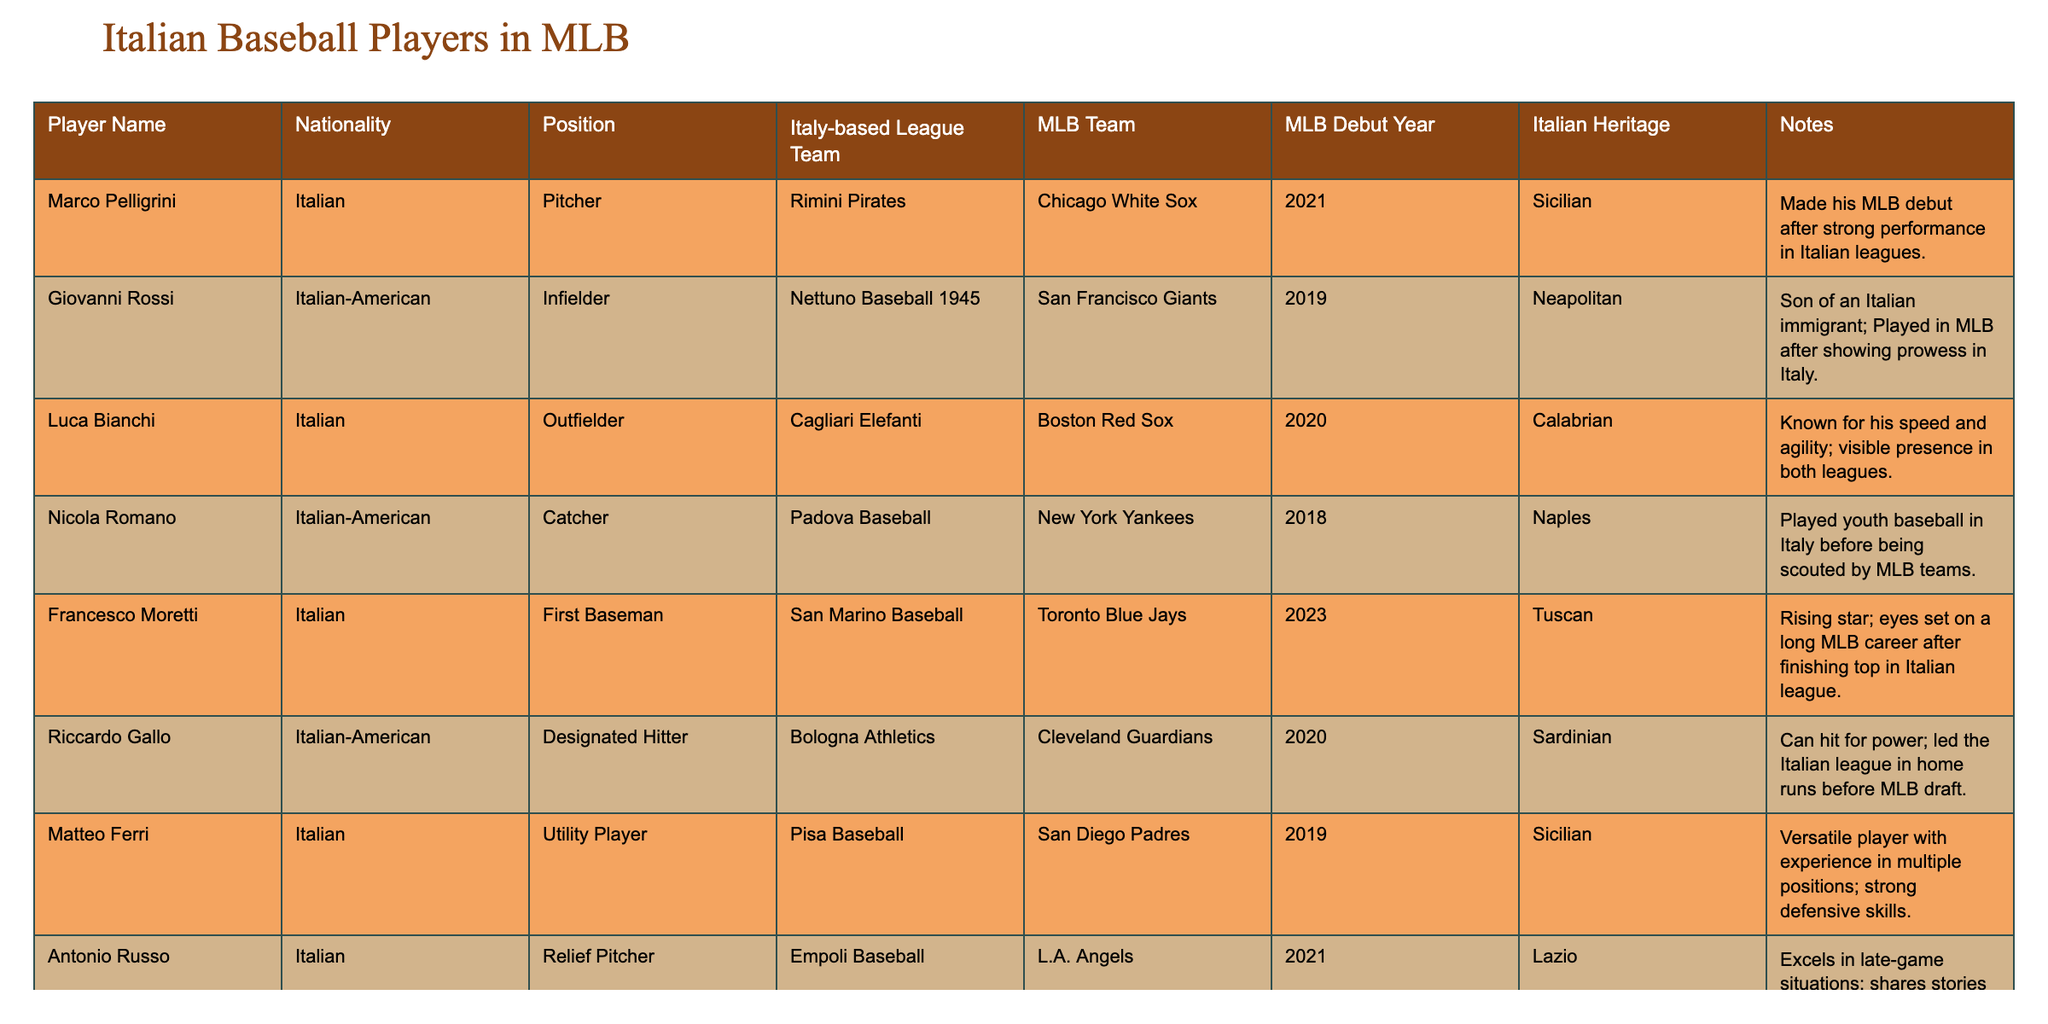What is the MLB team affiliation of Marco Pelligrini? Marco Pelligrini is listed under the "MLB Team" column in the table, which shows he is affiliated with the Chicago White Sox.
Answer: Chicago White Sox Which player debuted in MLB the earliest among the listed players? I will check the "MLB Debut Year" column for the earliest year. The earliest year is 2018, which corresponds to Nicola Romano.
Answer: Nicola Romano How many players have played for the San Diego Padres? By examining the "MLB Team" column, I see that only Matteo Ferri is associated with the San Diego Padres, so the total count is one.
Answer: 1 Is Francesco Moretti of Italian heritage? Looking at the "Italian Heritage" column, I can see that he has "Tuscan" listed as his heritage, which means he is Italian.
Answer: Yes Which player is most recently listed to have debuted in MLB? I will check the "MLB Debut Year" and identify the latest year mentioned, which is 2023 for Francesco Moretti.
Answer: Francesco Moretti What position does the player Giovanni Rossi play? By checking his entry under the "Position" column, Giovanni Rossi is noted as an Infielder.
Answer: Infielder How many players listed have Italian-American heritage? The "Nationality" column shows that two players, Giovanni Rossi and Riccardo Gallo, identify as Italian-American, so the total is two.
Answer: 2 Did any players from the table play for the New York Yankees? Referring to the "MLB Team" column, I find that Nicola Romano is listed as playing for the New York Yankees, confirming that at least one player has.
Answer: Yes Which player led the Italian league in home runs before being drafted? The table indicates that Riccardo Gallo led the Italian league in home runs before joining MLB according to the "Notes" column.
Answer: Riccardo Gallo How does the Italian heritage of Antonio Russo compare to that of Marco Pelligrini? Antonio Russo is noted as having heritage from Lazio, while Marco Pelligrini is Sicilian. Both are Italian, but from different regions.
Answer: Different regions (Lazio and Sicily) 